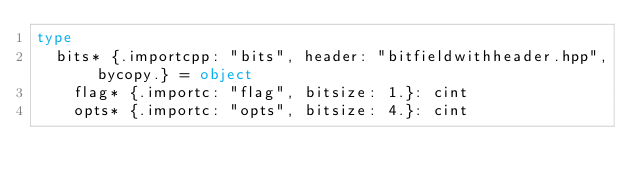<code> <loc_0><loc_0><loc_500><loc_500><_Nim_>type
  bits* {.importcpp: "bits", header: "bitfieldwithheader.hpp", bycopy.} = object
    flag* {.importc: "flag", bitsize: 1.}: cint
    opts* {.importc: "opts", bitsize: 4.}: cint

</code> 